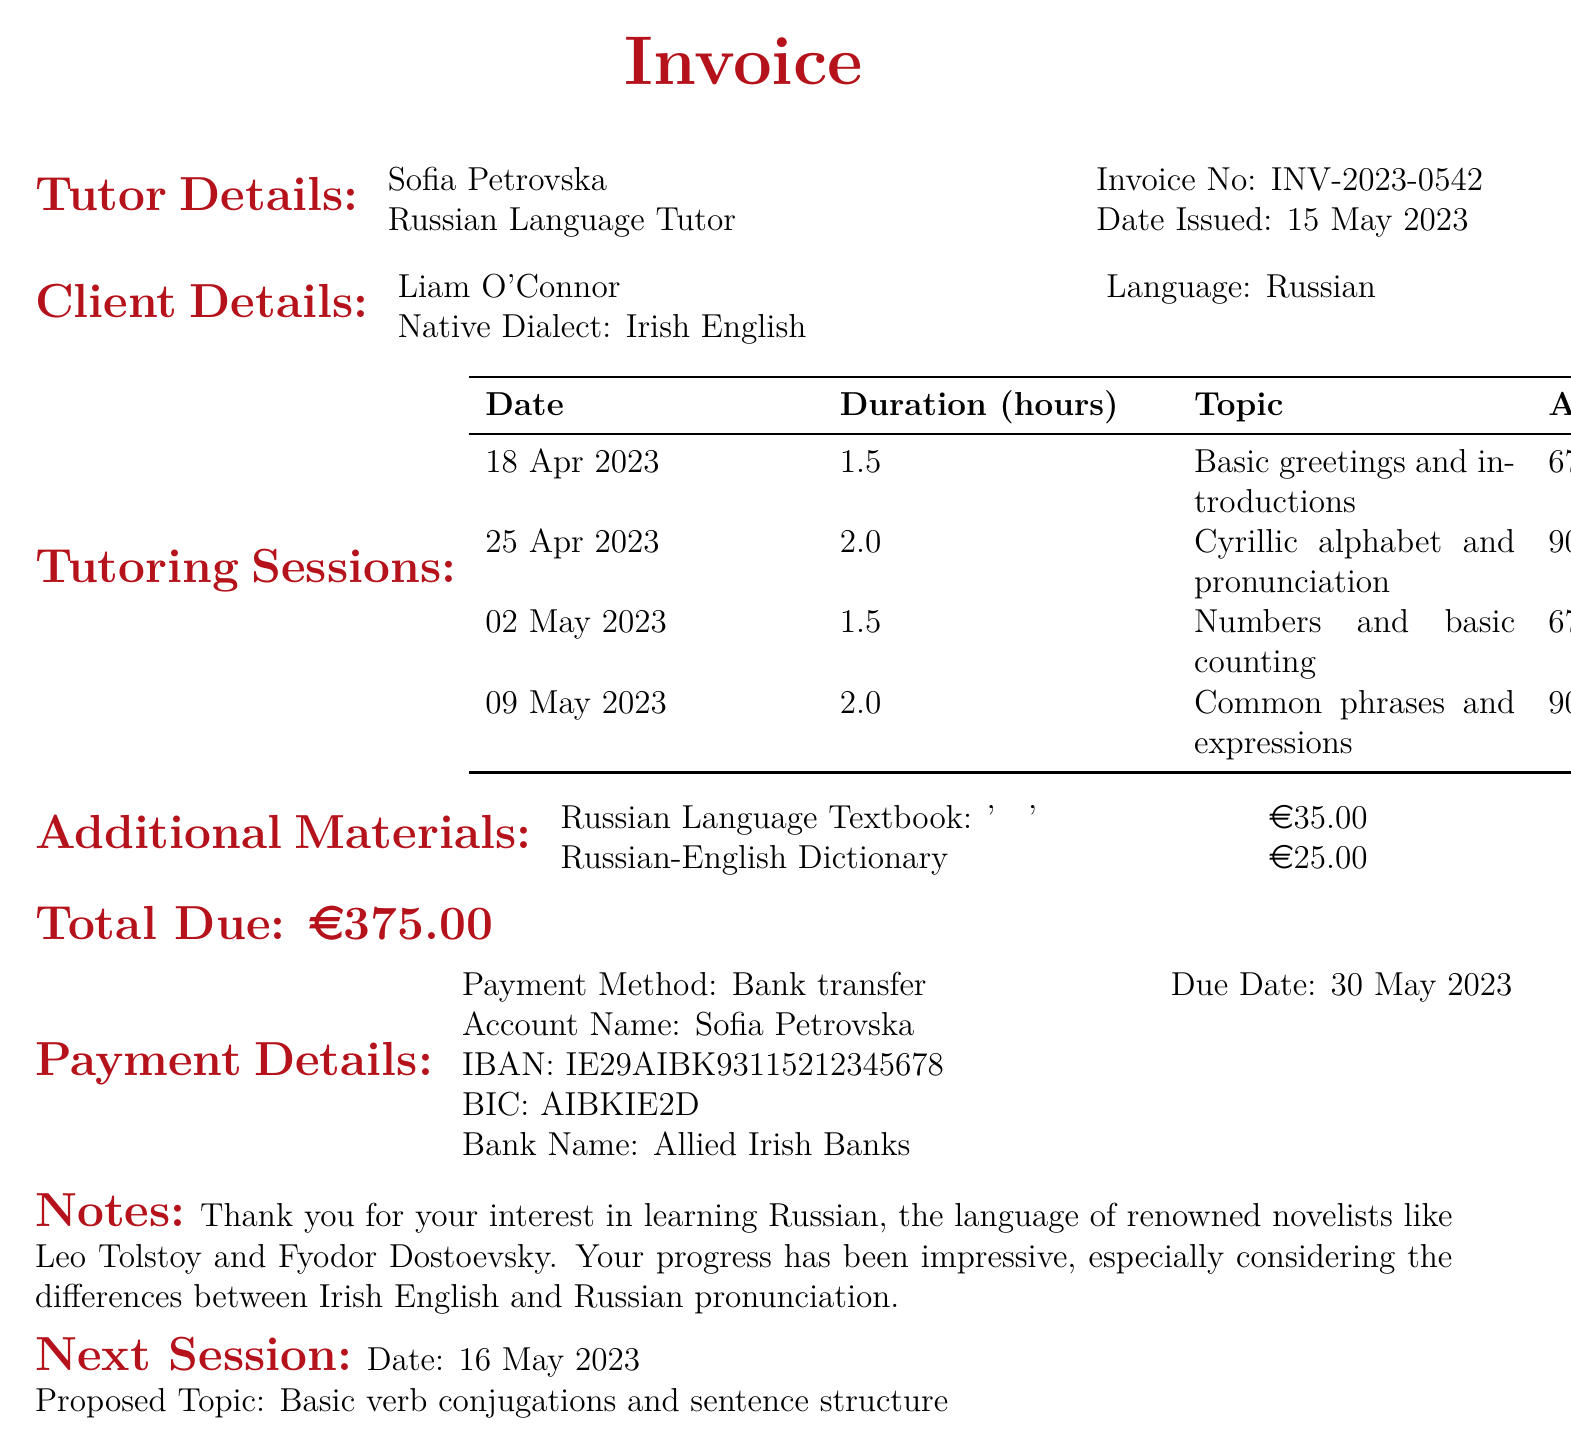What is the name of the tutor? The document lists Sofia Petrovska as the tutor's name.
Answer: Sofia Petrovska What is the hourly rate for tutoring sessions? The document states the hourly rate is €45.
Answer: €45 When was the invoice issued? The date issued is specified in the document as May 15, 2023.
Answer: May 15, 2023 What is the due date for payment? The due date for payment is mentioned as May 30, 2023.
Answer: May 30, 2023 What is the total amount due? The document indicates that the total due is €375.
Answer: €375 How many sessions were held in April 2023? The document details two sessions were held in April 2023.
Answer: 2 What topic is proposed for the next session? The proposed topic for the next session is stated as basic verb conjugations and sentence structure.
Answer: Basic verb conjugations and sentence structure What payment method is specified in the invoice? The payment method mentioned in the document is bank transfer.
Answer: Bank transfer What amount is charged for the Russian Language Textbook? The cost for the Russian Language Textbook is listed as €35.
Answer: €35 